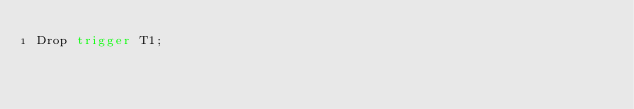<code> <loc_0><loc_0><loc_500><loc_500><_SQL_>Drop trigger T1;
</code> 